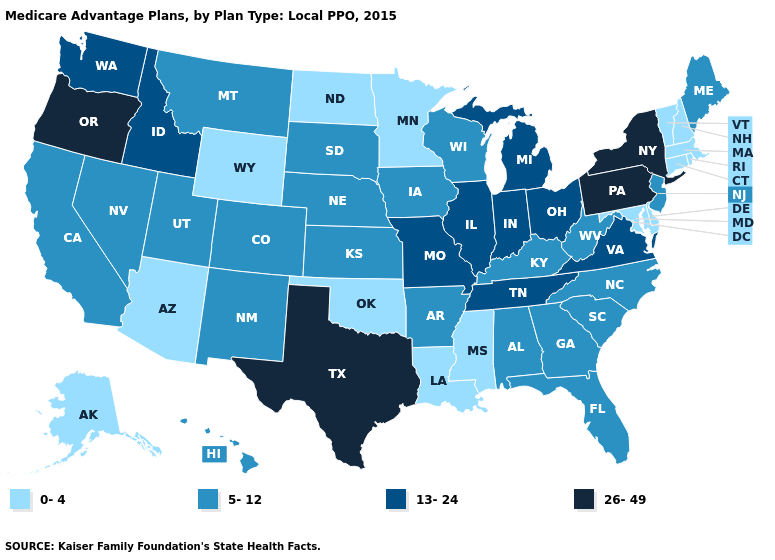Name the states that have a value in the range 0-4?
Short answer required. Alaska, Arizona, Connecticut, Delaware, Louisiana, Massachusetts, Maryland, Minnesota, Mississippi, North Dakota, New Hampshire, Oklahoma, Rhode Island, Vermont, Wyoming. Does New York have the same value as Pennsylvania?
Concise answer only. Yes. Among the states that border Nevada , which have the lowest value?
Concise answer only. Arizona. Name the states that have a value in the range 5-12?
Answer briefly. Alabama, Arkansas, California, Colorado, Florida, Georgia, Hawaii, Iowa, Kansas, Kentucky, Maine, Montana, North Carolina, Nebraska, New Jersey, New Mexico, Nevada, South Carolina, South Dakota, Utah, Wisconsin, West Virginia. What is the highest value in states that border Texas?
Answer briefly. 5-12. Name the states that have a value in the range 26-49?
Write a very short answer. New York, Oregon, Pennsylvania, Texas. Name the states that have a value in the range 13-24?
Quick response, please. Idaho, Illinois, Indiana, Michigan, Missouri, Ohio, Tennessee, Virginia, Washington. Name the states that have a value in the range 5-12?
Keep it brief. Alabama, Arkansas, California, Colorado, Florida, Georgia, Hawaii, Iowa, Kansas, Kentucky, Maine, Montana, North Carolina, Nebraska, New Jersey, New Mexico, Nevada, South Carolina, South Dakota, Utah, Wisconsin, West Virginia. Which states have the highest value in the USA?
Keep it brief. New York, Oregon, Pennsylvania, Texas. What is the value of Florida?
Concise answer only. 5-12. Name the states that have a value in the range 5-12?
Quick response, please. Alabama, Arkansas, California, Colorado, Florida, Georgia, Hawaii, Iowa, Kansas, Kentucky, Maine, Montana, North Carolina, Nebraska, New Jersey, New Mexico, Nevada, South Carolina, South Dakota, Utah, Wisconsin, West Virginia. What is the highest value in the Northeast ?
Give a very brief answer. 26-49. Among the states that border Florida , which have the lowest value?
Be succinct. Alabama, Georgia. Which states hav the highest value in the MidWest?
Write a very short answer. Illinois, Indiana, Michigan, Missouri, Ohio. Name the states that have a value in the range 26-49?
Be succinct. New York, Oregon, Pennsylvania, Texas. 